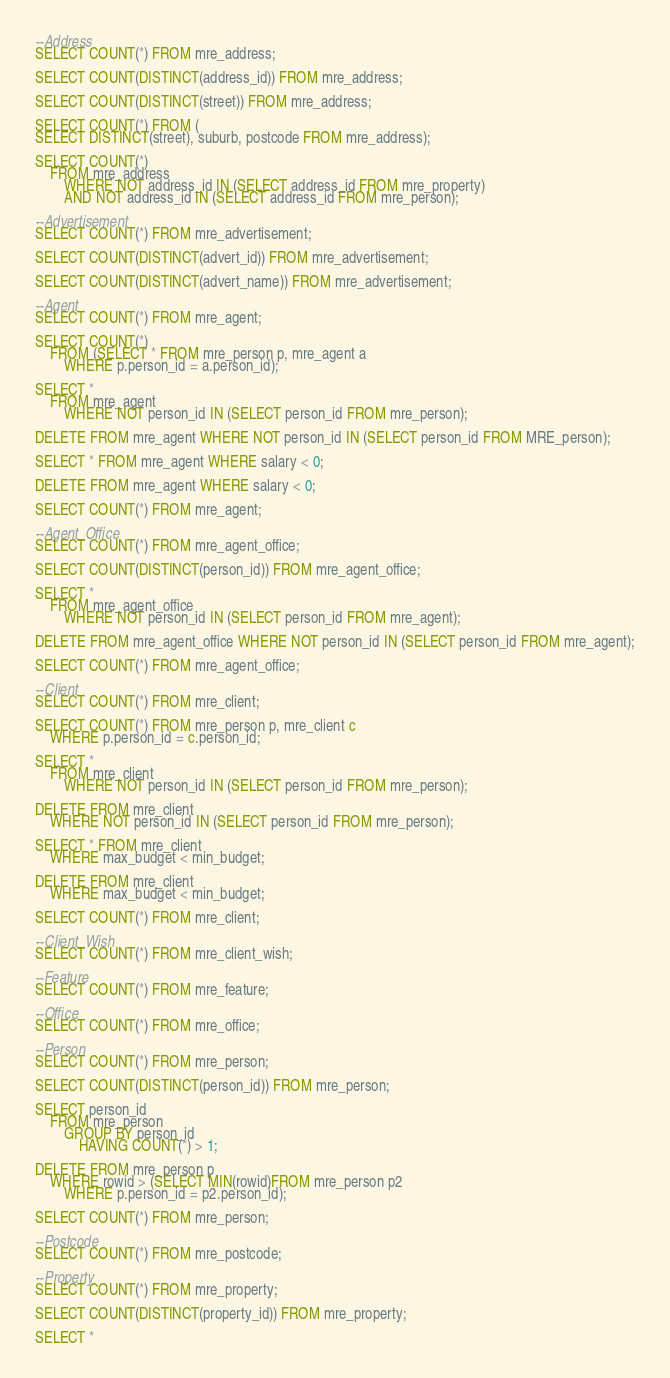Convert code to text. <code><loc_0><loc_0><loc_500><loc_500><_SQL_>--Address
SELECT COUNT(*) FROM mre_address;

SELECT COUNT(DISTINCT(address_id)) FROM mre_address;

SELECT COUNT(DISTINCT(street)) FROM mre_address;

SELECT COUNT(*) FROM (
SELECT DISTINCT(street), suburb, postcode FROM mre_address);

SELECT COUNT(*)
	FROM mre_address
		WHERE NOT address_id IN (SELECT address_id FROM mre_property)
		AND NOT address_id IN (SELECT address_id FROM mre_person);

--Advertisement
SELECT COUNT(*) FROM mre_advertisement;

SELECT COUNT(DISTINCT(advert_id)) FROM mre_advertisement;

SELECT COUNT(DISTINCT(advert_name)) FROM mre_advertisement; 

--Agent
SELECT COUNT(*) FROM mre_agent;

SELECT COUNT(*)
	FROM (SELECT * FROM mre_person p, mre_agent a
		WHERE p.person_id = a.person_id);

SELECT *
	FROM mre_agent
        WHERE NOT person_id IN (SELECT person_id FROM mre_person);
		
DELETE FROM mre_agent WHERE NOT person_id IN (SELECT person_id FROM MRE_person);

SELECT * FROM mre_agent WHERE salary < 0;

DELETE FROM mre_agent WHERE salary < 0;

SELECT COUNT(*) FROM mre_agent;

--Agent_Office
SELECT COUNT(*) FROM mre_agent_office;

SELECT COUNT(DISTINCT(person_id)) FROM mre_agent_office;

SELECT *
    FROM mre_agent_office
        WHERE NOT person_id IN (SELECT person_id FROM mre_agent);

DELETE FROM mre_agent_office WHERE NOT person_id IN (SELECT person_id FROM mre_agent);

SELECT COUNT(*) FROM mre_agent_office;

--Client
SELECT COUNT(*) FROM mre_client;

SELECT COUNT(*) FROM mre_person p, mre_client c
	WHERE p.person_id = c.person_id;
    
SELECT *
    FROM mre_client
        WHERE NOT person_id IN (SELECT person_id FROM mre_person);

DELETE FROM mre_client
	WHERE NOT person_id IN (SELECT person_id FROM mre_person);

SELECT * FROM mre_client
	WHERE max_budget < min_budget;

DELETE FROM mre_client
	WHERE max_budget < min_budget;

SELECT COUNT(*) FROM mre_client;

--Client_Wish
SELECT COUNT(*) FROM mre_client_wish;

--Feature
SELECT COUNT(*) FROM mre_feature;

--Office
SELECT COUNT(*) FROM mre_office;

--Person
SELECT COUNT(*) FROM mre_person;

SELECT COUNT(DISTINCT(person_id)) FROM mre_person;

SELECT person_id
	FROM mre_person
		GROUP BY person_id
			HAVING COUNT(*) > 1;

DELETE FROM mre_person p
	WHERE rowid > (SELECT MIN(rowid)FROM mre_person p2
		WHERE p.person_id = p2.person_id);

SELECT COUNT(*) FROM mre_person;

--Postcode
SELECT COUNT(*) FROM mre_postcode;

--Property
SELECT COUNT(*) FROM mre_property;

SELECT COUNT(DISTINCT(property_id)) FROM mre_property;

SELECT *</code> 